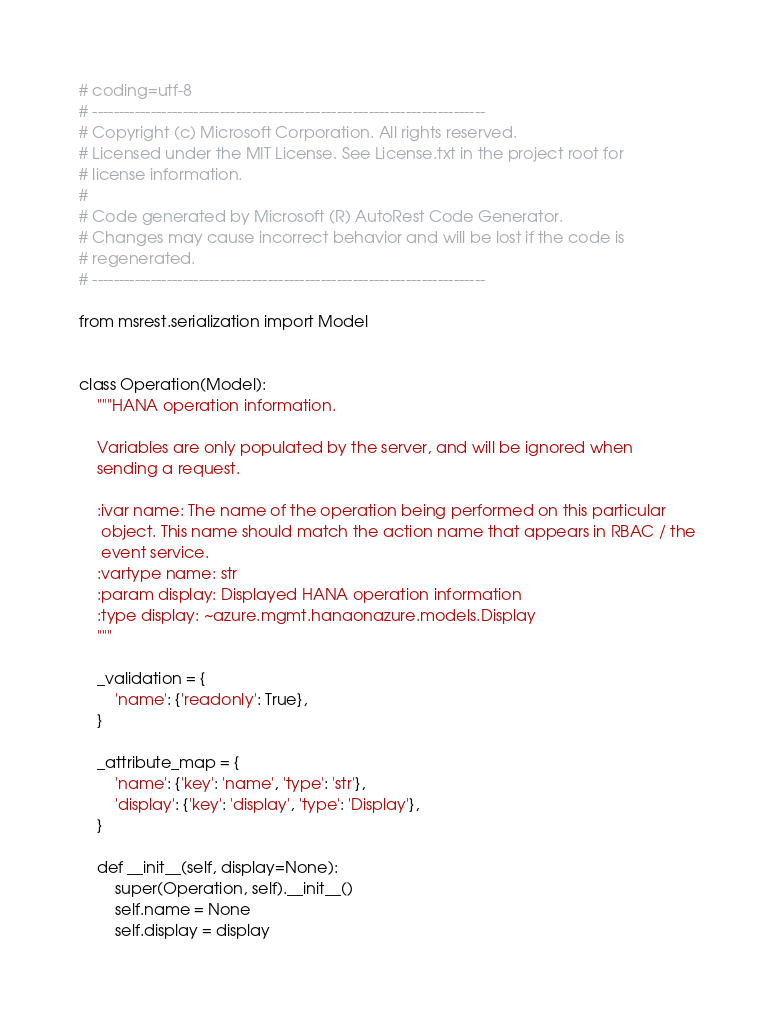<code> <loc_0><loc_0><loc_500><loc_500><_Python_># coding=utf-8
# --------------------------------------------------------------------------
# Copyright (c) Microsoft Corporation. All rights reserved.
# Licensed under the MIT License. See License.txt in the project root for
# license information.
#
# Code generated by Microsoft (R) AutoRest Code Generator.
# Changes may cause incorrect behavior and will be lost if the code is
# regenerated.
# --------------------------------------------------------------------------

from msrest.serialization import Model


class Operation(Model):
    """HANA operation information.

    Variables are only populated by the server, and will be ignored when
    sending a request.

    :ivar name: The name of the operation being performed on this particular
     object. This name should match the action name that appears in RBAC / the
     event service.
    :vartype name: str
    :param display: Displayed HANA operation information
    :type display: ~azure.mgmt.hanaonazure.models.Display
    """

    _validation = {
        'name': {'readonly': True},
    }

    _attribute_map = {
        'name': {'key': 'name', 'type': 'str'},
        'display': {'key': 'display', 'type': 'Display'},
    }

    def __init__(self, display=None):
        super(Operation, self).__init__()
        self.name = None
        self.display = display
</code> 